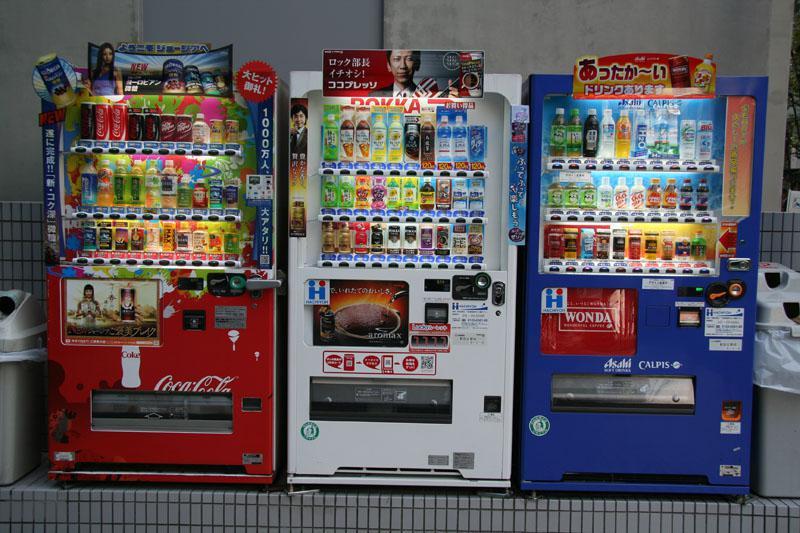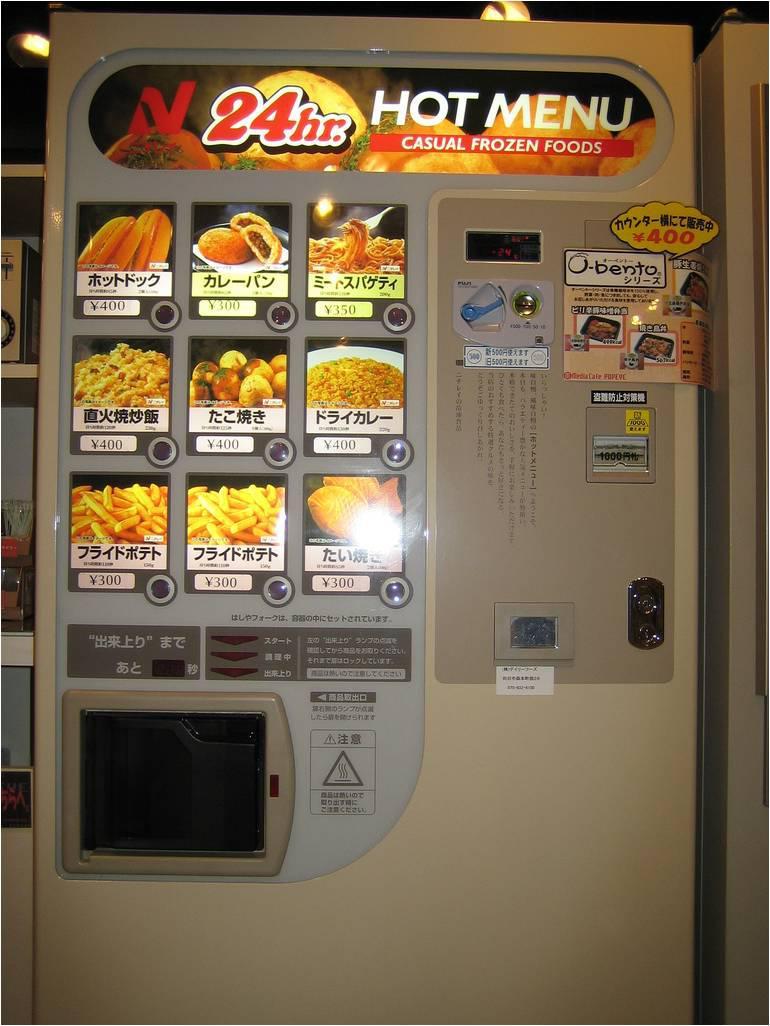The first image is the image on the left, the second image is the image on the right. Analyze the images presented: Is the assertion "A trio of vending machines includes at least one red one." valid? Answer yes or no. Yes. The first image is the image on the left, the second image is the image on the right. For the images shown, is this caption "There are three beverage vending machines in one of the images." true? Answer yes or no. Yes. 